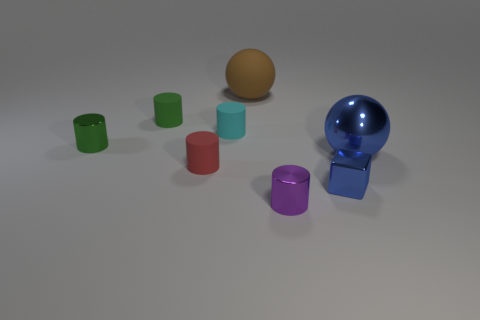Is there any other thing that has the same material as the red thing?
Your answer should be compact. Yes. Are there an equal number of cyan things that are on the right side of the cyan matte cylinder and tiny metallic cylinders in front of the blue shiny sphere?
Give a very brief answer. No. There is a blue object that is the same shape as the big brown thing; what size is it?
Your response must be concise. Large. What shape is the blue shiny object in front of the small red cylinder?
Your answer should be very brief. Cube. Are the big ball left of the cube and the tiny blue object that is in front of the small red matte thing made of the same material?
Offer a terse response. No. What is the shape of the tiny blue shiny thing?
Make the answer very short. Cube. Is the number of big brown rubber spheres that are in front of the small green rubber cylinder the same as the number of small blue objects?
Offer a terse response. No. There is a metallic ball that is the same color as the tiny cube; what is its size?
Your answer should be very brief. Large. Are there any small blue cubes made of the same material as the cyan thing?
Offer a terse response. No. There is a blue metal object behind the tiny red rubber cylinder; is its shape the same as the rubber object that is in front of the cyan rubber thing?
Provide a short and direct response. No. 